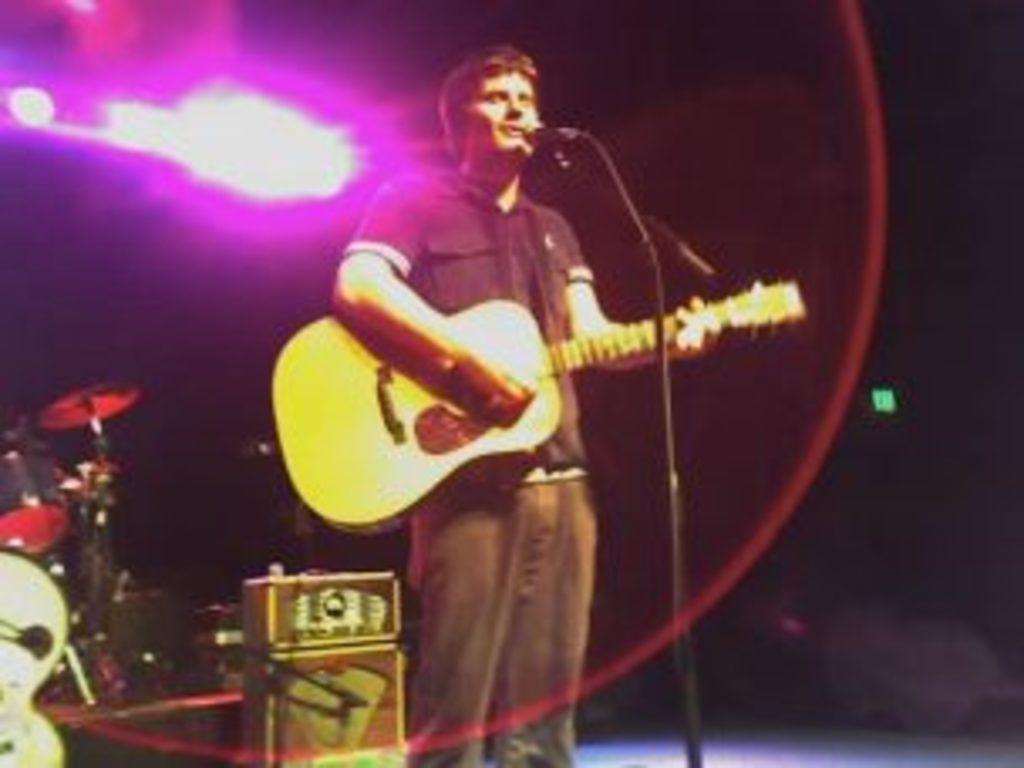Please provide a concise description of this image. As we can see in the image there is a man singing song and holding guitar in his hands. On the left side there are drums. 